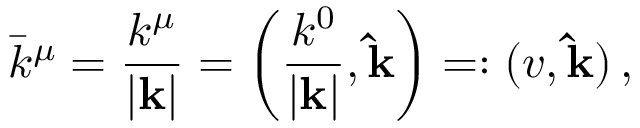<formula> <loc_0><loc_0><loc_500><loc_500>\bar { k } ^ { \mu } = \frac { k ^ { \mu } } { | { k } | } = \left ( \frac { k ^ { 0 } } { | { k } | } , { \hat { k } } \right ) = \colon ( v , { \hat { k } } ) \, ,</formula> 